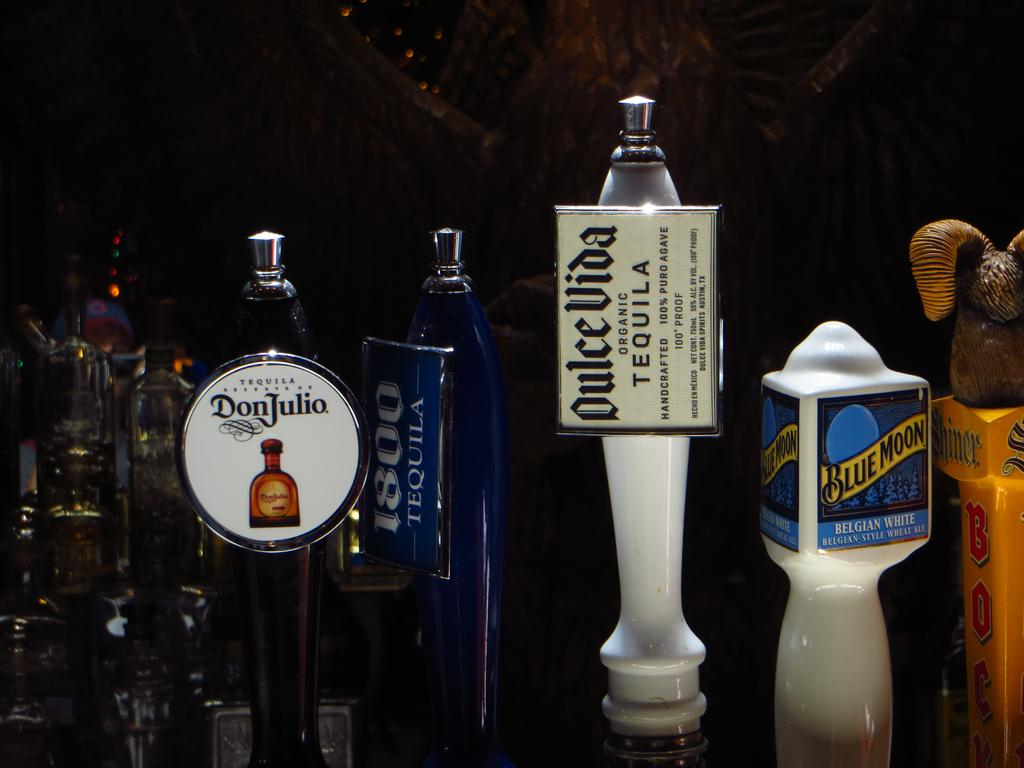<image>
Describe the image concisely. the word tequila is on the white item 